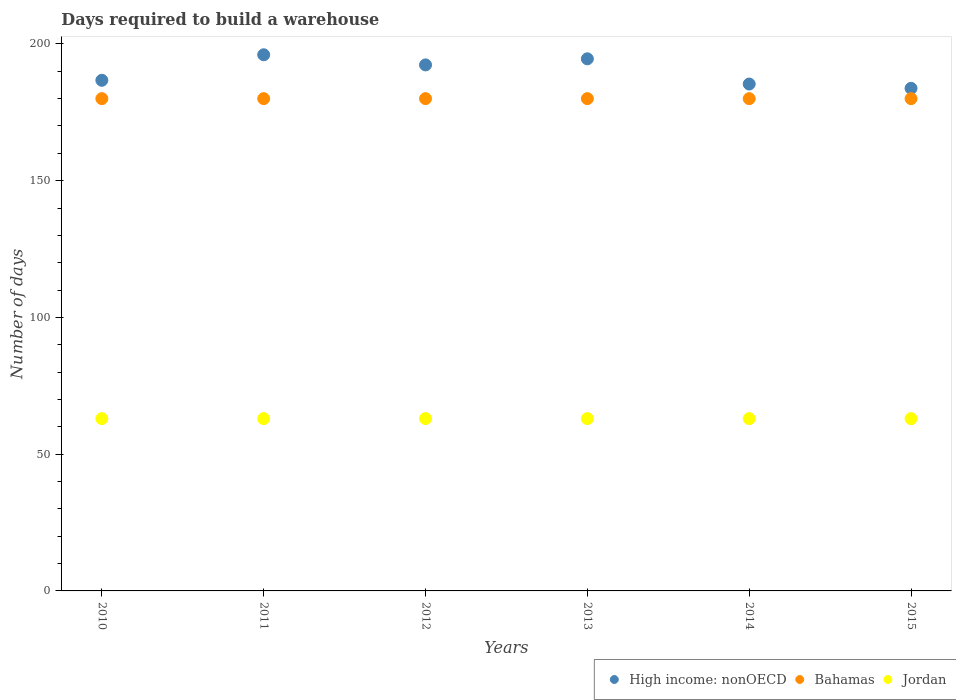What is the days required to build a warehouse in in Jordan in 2015?
Your answer should be compact. 63. Across all years, what is the maximum days required to build a warehouse in in High income: nonOECD?
Make the answer very short. 196.04. Across all years, what is the minimum days required to build a warehouse in in High income: nonOECD?
Keep it short and to the point. 183.77. What is the total days required to build a warehouse in in High income: nonOECD in the graph?
Provide a succinct answer. 1138.74. What is the difference between the days required to build a warehouse in in Bahamas in 2011 and the days required to build a warehouse in in High income: nonOECD in 2013?
Keep it short and to the point. -14.56. What is the average days required to build a warehouse in in High income: nonOECD per year?
Your answer should be very brief. 189.79. In the year 2010, what is the difference between the days required to build a warehouse in in Bahamas and days required to build a warehouse in in High income: nonOECD?
Your answer should be very brief. -6.71. What is the ratio of the days required to build a warehouse in in High income: nonOECD in 2012 to that in 2015?
Your response must be concise. 1.05. What is the difference between the highest and the second highest days required to build a warehouse in in Bahamas?
Offer a very short reply. 0. In how many years, is the days required to build a warehouse in in Jordan greater than the average days required to build a warehouse in in Jordan taken over all years?
Provide a succinct answer. 0. Is it the case that in every year, the sum of the days required to build a warehouse in in High income: nonOECD and days required to build a warehouse in in Jordan  is greater than the days required to build a warehouse in in Bahamas?
Make the answer very short. Yes. Does the days required to build a warehouse in in Bahamas monotonically increase over the years?
Provide a succinct answer. No. Is the days required to build a warehouse in in Bahamas strictly greater than the days required to build a warehouse in in High income: nonOECD over the years?
Offer a terse response. No. What is the difference between two consecutive major ticks on the Y-axis?
Offer a very short reply. 50. Are the values on the major ticks of Y-axis written in scientific E-notation?
Your response must be concise. No. Does the graph contain any zero values?
Your answer should be compact. No. Does the graph contain grids?
Offer a terse response. No. How many legend labels are there?
Offer a very short reply. 3. How are the legend labels stacked?
Make the answer very short. Horizontal. What is the title of the graph?
Provide a short and direct response. Days required to build a warehouse. What is the label or title of the X-axis?
Provide a short and direct response. Years. What is the label or title of the Y-axis?
Your response must be concise. Number of days. What is the Number of days in High income: nonOECD in 2010?
Your answer should be compact. 186.71. What is the Number of days in Bahamas in 2010?
Keep it short and to the point. 180. What is the Number of days in High income: nonOECD in 2011?
Your answer should be very brief. 196.04. What is the Number of days of Bahamas in 2011?
Ensure brevity in your answer.  180. What is the Number of days in High income: nonOECD in 2012?
Make the answer very short. 192.33. What is the Number of days in Bahamas in 2012?
Your answer should be very brief. 180. What is the Number of days of Jordan in 2012?
Offer a very short reply. 63. What is the Number of days of High income: nonOECD in 2013?
Make the answer very short. 194.56. What is the Number of days of Bahamas in 2013?
Your answer should be very brief. 180. What is the Number of days in Jordan in 2013?
Provide a succinct answer. 63. What is the Number of days of High income: nonOECD in 2014?
Provide a short and direct response. 185.34. What is the Number of days of Bahamas in 2014?
Your answer should be very brief. 180. What is the Number of days of Jordan in 2014?
Make the answer very short. 63. What is the Number of days of High income: nonOECD in 2015?
Make the answer very short. 183.77. What is the Number of days of Bahamas in 2015?
Provide a succinct answer. 180. What is the Number of days in Jordan in 2015?
Provide a short and direct response. 63. Across all years, what is the maximum Number of days of High income: nonOECD?
Provide a short and direct response. 196.04. Across all years, what is the maximum Number of days of Bahamas?
Your response must be concise. 180. Across all years, what is the maximum Number of days of Jordan?
Offer a very short reply. 63. Across all years, what is the minimum Number of days of High income: nonOECD?
Your answer should be very brief. 183.77. Across all years, what is the minimum Number of days of Bahamas?
Keep it short and to the point. 180. Across all years, what is the minimum Number of days of Jordan?
Keep it short and to the point. 63. What is the total Number of days in High income: nonOECD in the graph?
Your response must be concise. 1138.74. What is the total Number of days in Bahamas in the graph?
Provide a short and direct response. 1080. What is the total Number of days in Jordan in the graph?
Offer a very short reply. 378. What is the difference between the Number of days of High income: nonOECD in 2010 and that in 2011?
Make the answer very short. -9.33. What is the difference between the Number of days in Jordan in 2010 and that in 2011?
Make the answer very short. 0. What is the difference between the Number of days of High income: nonOECD in 2010 and that in 2012?
Give a very brief answer. -5.62. What is the difference between the Number of days in Bahamas in 2010 and that in 2012?
Offer a terse response. 0. What is the difference between the Number of days in Jordan in 2010 and that in 2012?
Give a very brief answer. 0. What is the difference between the Number of days of High income: nonOECD in 2010 and that in 2013?
Offer a very short reply. -7.85. What is the difference between the Number of days of Jordan in 2010 and that in 2013?
Your response must be concise. 0. What is the difference between the Number of days in High income: nonOECD in 2010 and that in 2014?
Provide a succinct answer. 1.37. What is the difference between the Number of days in High income: nonOECD in 2010 and that in 2015?
Offer a very short reply. 2.94. What is the difference between the Number of days in Bahamas in 2010 and that in 2015?
Provide a short and direct response. 0. What is the difference between the Number of days of High income: nonOECD in 2011 and that in 2012?
Ensure brevity in your answer.  3.71. What is the difference between the Number of days of Bahamas in 2011 and that in 2012?
Offer a very short reply. 0. What is the difference between the Number of days in High income: nonOECD in 2011 and that in 2013?
Give a very brief answer. 1.48. What is the difference between the Number of days in Jordan in 2011 and that in 2013?
Give a very brief answer. 0. What is the difference between the Number of days in High income: nonOECD in 2011 and that in 2014?
Ensure brevity in your answer.  10.7. What is the difference between the Number of days in Bahamas in 2011 and that in 2014?
Offer a very short reply. 0. What is the difference between the Number of days of Jordan in 2011 and that in 2014?
Provide a short and direct response. 0. What is the difference between the Number of days of High income: nonOECD in 2011 and that in 2015?
Give a very brief answer. 12.27. What is the difference between the Number of days in Jordan in 2011 and that in 2015?
Your response must be concise. 0. What is the difference between the Number of days in High income: nonOECD in 2012 and that in 2013?
Provide a succinct answer. -2.22. What is the difference between the Number of days in Bahamas in 2012 and that in 2013?
Your answer should be compact. 0. What is the difference between the Number of days in Jordan in 2012 and that in 2013?
Offer a terse response. 0. What is the difference between the Number of days in High income: nonOECD in 2012 and that in 2014?
Make the answer very short. 6.99. What is the difference between the Number of days in Bahamas in 2012 and that in 2014?
Offer a terse response. 0. What is the difference between the Number of days of High income: nonOECD in 2012 and that in 2015?
Provide a succinct answer. 8.57. What is the difference between the Number of days in High income: nonOECD in 2013 and that in 2014?
Your response must be concise. 9.22. What is the difference between the Number of days in High income: nonOECD in 2013 and that in 2015?
Provide a short and direct response. 10.79. What is the difference between the Number of days of Bahamas in 2013 and that in 2015?
Provide a succinct answer. 0. What is the difference between the Number of days of High income: nonOECD in 2014 and that in 2015?
Keep it short and to the point. 1.57. What is the difference between the Number of days of High income: nonOECD in 2010 and the Number of days of Bahamas in 2011?
Ensure brevity in your answer.  6.71. What is the difference between the Number of days in High income: nonOECD in 2010 and the Number of days in Jordan in 2011?
Offer a terse response. 123.71. What is the difference between the Number of days of Bahamas in 2010 and the Number of days of Jordan in 2011?
Your answer should be very brief. 117. What is the difference between the Number of days of High income: nonOECD in 2010 and the Number of days of Bahamas in 2012?
Offer a terse response. 6.71. What is the difference between the Number of days in High income: nonOECD in 2010 and the Number of days in Jordan in 2012?
Ensure brevity in your answer.  123.71. What is the difference between the Number of days in Bahamas in 2010 and the Number of days in Jordan in 2012?
Offer a very short reply. 117. What is the difference between the Number of days of High income: nonOECD in 2010 and the Number of days of Bahamas in 2013?
Give a very brief answer. 6.71. What is the difference between the Number of days of High income: nonOECD in 2010 and the Number of days of Jordan in 2013?
Offer a terse response. 123.71. What is the difference between the Number of days in Bahamas in 2010 and the Number of days in Jordan in 2013?
Your answer should be compact. 117. What is the difference between the Number of days in High income: nonOECD in 2010 and the Number of days in Bahamas in 2014?
Make the answer very short. 6.71. What is the difference between the Number of days in High income: nonOECD in 2010 and the Number of days in Jordan in 2014?
Ensure brevity in your answer.  123.71. What is the difference between the Number of days in Bahamas in 2010 and the Number of days in Jordan in 2014?
Offer a very short reply. 117. What is the difference between the Number of days in High income: nonOECD in 2010 and the Number of days in Bahamas in 2015?
Your answer should be very brief. 6.71. What is the difference between the Number of days of High income: nonOECD in 2010 and the Number of days of Jordan in 2015?
Ensure brevity in your answer.  123.71. What is the difference between the Number of days of Bahamas in 2010 and the Number of days of Jordan in 2015?
Provide a short and direct response. 117. What is the difference between the Number of days of High income: nonOECD in 2011 and the Number of days of Bahamas in 2012?
Offer a terse response. 16.04. What is the difference between the Number of days in High income: nonOECD in 2011 and the Number of days in Jordan in 2012?
Offer a very short reply. 133.04. What is the difference between the Number of days of Bahamas in 2011 and the Number of days of Jordan in 2012?
Your response must be concise. 117. What is the difference between the Number of days of High income: nonOECD in 2011 and the Number of days of Bahamas in 2013?
Your response must be concise. 16.04. What is the difference between the Number of days of High income: nonOECD in 2011 and the Number of days of Jordan in 2013?
Make the answer very short. 133.04. What is the difference between the Number of days of Bahamas in 2011 and the Number of days of Jordan in 2013?
Ensure brevity in your answer.  117. What is the difference between the Number of days of High income: nonOECD in 2011 and the Number of days of Bahamas in 2014?
Provide a short and direct response. 16.04. What is the difference between the Number of days in High income: nonOECD in 2011 and the Number of days in Jordan in 2014?
Give a very brief answer. 133.04. What is the difference between the Number of days of Bahamas in 2011 and the Number of days of Jordan in 2014?
Keep it short and to the point. 117. What is the difference between the Number of days of High income: nonOECD in 2011 and the Number of days of Bahamas in 2015?
Make the answer very short. 16.04. What is the difference between the Number of days in High income: nonOECD in 2011 and the Number of days in Jordan in 2015?
Your response must be concise. 133.04. What is the difference between the Number of days in Bahamas in 2011 and the Number of days in Jordan in 2015?
Make the answer very short. 117. What is the difference between the Number of days of High income: nonOECD in 2012 and the Number of days of Bahamas in 2013?
Give a very brief answer. 12.33. What is the difference between the Number of days in High income: nonOECD in 2012 and the Number of days in Jordan in 2013?
Keep it short and to the point. 129.33. What is the difference between the Number of days in Bahamas in 2012 and the Number of days in Jordan in 2013?
Keep it short and to the point. 117. What is the difference between the Number of days of High income: nonOECD in 2012 and the Number of days of Bahamas in 2014?
Offer a very short reply. 12.33. What is the difference between the Number of days of High income: nonOECD in 2012 and the Number of days of Jordan in 2014?
Keep it short and to the point. 129.33. What is the difference between the Number of days in Bahamas in 2012 and the Number of days in Jordan in 2014?
Keep it short and to the point. 117. What is the difference between the Number of days in High income: nonOECD in 2012 and the Number of days in Bahamas in 2015?
Your response must be concise. 12.33. What is the difference between the Number of days in High income: nonOECD in 2012 and the Number of days in Jordan in 2015?
Your answer should be compact. 129.33. What is the difference between the Number of days in Bahamas in 2012 and the Number of days in Jordan in 2015?
Keep it short and to the point. 117. What is the difference between the Number of days in High income: nonOECD in 2013 and the Number of days in Bahamas in 2014?
Offer a terse response. 14.56. What is the difference between the Number of days of High income: nonOECD in 2013 and the Number of days of Jordan in 2014?
Your answer should be very brief. 131.56. What is the difference between the Number of days in Bahamas in 2013 and the Number of days in Jordan in 2014?
Your answer should be compact. 117. What is the difference between the Number of days in High income: nonOECD in 2013 and the Number of days in Bahamas in 2015?
Offer a very short reply. 14.56. What is the difference between the Number of days in High income: nonOECD in 2013 and the Number of days in Jordan in 2015?
Your answer should be very brief. 131.56. What is the difference between the Number of days of Bahamas in 2013 and the Number of days of Jordan in 2015?
Provide a short and direct response. 117. What is the difference between the Number of days of High income: nonOECD in 2014 and the Number of days of Bahamas in 2015?
Ensure brevity in your answer.  5.34. What is the difference between the Number of days of High income: nonOECD in 2014 and the Number of days of Jordan in 2015?
Give a very brief answer. 122.34. What is the difference between the Number of days in Bahamas in 2014 and the Number of days in Jordan in 2015?
Your answer should be very brief. 117. What is the average Number of days in High income: nonOECD per year?
Ensure brevity in your answer.  189.79. What is the average Number of days of Bahamas per year?
Give a very brief answer. 180. What is the average Number of days of Jordan per year?
Offer a very short reply. 63. In the year 2010, what is the difference between the Number of days of High income: nonOECD and Number of days of Bahamas?
Offer a very short reply. 6.71. In the year 2010, what is the difference between the Number of days of High income: nonOECD and Number of days of Jordan?
Provide a succinct answer. 123.71. In the year 2010, what is the difference between the Number of days of Bahamas and Number of days of Jordan?
Provide a short and direct response. 117. In the year 2011, what is the difference between the Number of days of High income: nonOECD and Number of days of Bahamas?
Keep it short and to the point. 16.04. In the year 2011, what is the difference between the Number of days of High income: nonOECD and Number of days of Jordan?
Provide a short and direct response. 133.04. In the year 2011, what is the difference between the Number of days of Bahamas and Number of days of Jordan?
Give a very brief answer. 117. In the year 2012, what is the difference between the Number of days of High income: nonOECD and Number of days of Bahamas?
Your answer should be very brief. 12.33. In the year 2012, what is the difference between the Number of days in High income: nonOECD and Number of days in Jordan?
Offer a very short reply. 129.33. In the year 2012, what is the difference between the Number of days in Bahamas and Number of days in Jordan?
Your response must be concise. 117. In the year 2013, what is the difference between the Number of days of High income: nonOECD and Number of days of Bahamas?
Your answer should be compact. 14.56. In the year 2013, what is the difference between the Number of days of High income: nonOECD and Number of days of Jordan?
Your answer should be compact. 131.56. In the year 2013, what is the difference between the Number of days of Bahamas and Number of days of Jordan?
Offer a very short reply. 117. In the year 2014, what is the difference between the Number of days of High income: nonOECD and Number of days of Bahamas?
Offer a very short reply. 5.34. In the year 2014, what is the difference between the Number of days of High income: nonOECD and Number of days of Jordan?
Your answer should be very brief. 122.34. In the year 2014, what is the difference between the Number of days in Bahamas and Number of days in Jordan?
Provide a succinct answer. 117. In the year 2015, what is the difference between the Number of days in High income: nonOECD and Number of days in Bahamas?
Make the answer very short. 3.77. In the year 2015, what is the difference between the Number of days in High income: nonOECD and Number of days in Jordan?
Your response must be concise. 120.77. In the year 2015, what is the difference between the Number of days in Bahamas and Number of days in Jordan?
Provide a succinct answer. 117. What is the ratio of the Number of days of High income: nonOECD in 2010 to that in 2011?
Provide a succinct answer. 0.95. What is the ratio of the Number of days of High income: nonOECD in 2010 to that in 2012?
Your response must be concise. 0.97. What is the ratio of the Number of days in Jordan in 2010 to that in 2012?
Your response must be concise. 1. What is the ratio of the Number of days in High income: nonOECD in 2010 to that in 2013?
Your answer should be very brief. 0.96. What is the ratio of the Number of days in Bahamas in 2010 to that in 2013?
Offer a very short reply. 1. What is the ratio of the Number of days in Jordan in 2010 to that in 2013?
Ensure brevity in your answer.  1. What is the ratio of the Number of days of High income: nonOECD in 2010 to that in 2014?
Provide a short and direct response. 1.01. What is the ratio of the Number of days of Jordan in 2010 to that in 2014?
Your response must be concise. 1. What is the ratio of the Number of days of Jordan in 2010 to that in 2015?
Offer a terse response. 1. What is the ratio of the Number of days of High income: nonOECD in 2011 to that in 2012?
Your response must be concise. 1.02. What is the ratio of the Number of days of High income: nonOECD in 2011 to that in 2013?
Provide a succinct answer. 1.01. What is the ratio of the Number of days in Jordan in 2011 to that in 2013?
Your answer should be compact. 1. What is the ratio of the Number of days in High income: nonOECD in 2011 to that in 2014?
Your answer should be very brief. 1.06. What is the ratio of the Number of days in High income: nonOECD in 2011 to that in 2015?
Provide a short and direct response. 1.07. What is the ratio of the Number of days of Jordan in 2011 to that in 2015?
Provide a succinct answer. 1. What is the ratio of the Number of days in High income: nonOECD in 2012 to that in 2013?
Your answer should be very brief. 0.99. What is the ratio of the Number of days of Bahamas in 2012 to that in 2013?
Provide a succinct answer. 1. What is the ratio of the Number of days of Jordan in 2012 to that in 2013?
Your answer should be compact. 1. What is the ratio of the Number of days in High income: nonOECD in 2012 to that in 2014?
Offer a very short reply. 1.04. What is the ratio of the Number of days in Bahamas in 2012 to that in 2014?
Offer a very short reply. 1. What is the ratio of the Number of days in Jordan in 2012 to that in 2014?
Give a very brief answer. 1. What is the ratio of the Number of days in High income: nonOECD in 2012 to that in 2015?
Your response must be concise. 1.05. What is the ratio of the Number of days of High income: nonOECD in 2013 to that in 2014?
Your response must be concise. 1.05. What is the ratio of the Number of days of Jordan in 2013 to that in 2014?
Ensure brevity in your answer.  1. What is the ratio of the Number of days in High income: nonOECD in 2013 to that in 2015?
Make the answer very short. 1.06. What is the ratio of the Number of days in Bahamas in 2013 to that in 2015?
Offer a very short reply. 1. What is the ratio of the Number of days of High income: nonOECD in 2014 to that in 2015?
Offer a very short reply. 1.01. What is the difference between the highest and the second highest Number of days of High income: nonOECD?
Give a very brief answer. 1.48. What is the difference between the highest and the second highest Number of days of Bahamas?
Your answer should be very brief. 0. What is the difference between the highest and the lowest Number of days of High income: nonOECD?
Offer a terse response. 12.27. What is the difference between the highest and the lowest Number of days in Bahamas?
Give a very brief answer. 0. What is the difference between the highest and the lowest Number of days in Jordan?
Give a very brief answer. 0. 